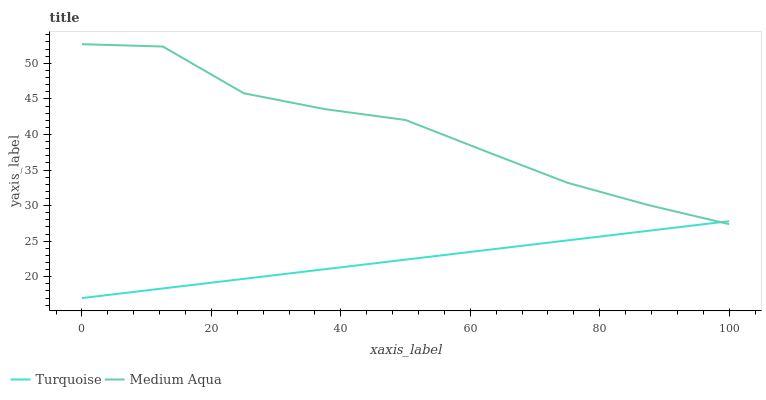Does Turquoise have the minimum area under the curve?
Answer yes or no. Yes. Does Medium Aqua have the minimum area under the curve?
Answer yes or no. No. Is Medium Aqua the smoothest?
Answer yes or no. No. Does Medium Aqua have the lowest value?
Answer yes or no. No. 